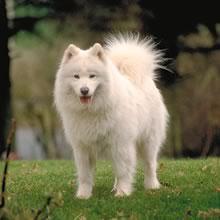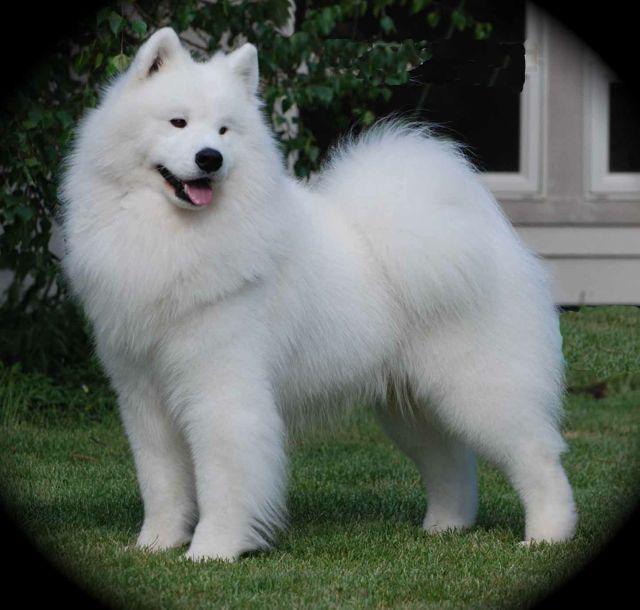The first image is the image on the left, the second image is the image on the right. Analyze the images presented: Is the assertion "One of the images shows an adult dog with a puppy on the grass." valid? Answer yes or no. No. The first image is the image on the left, the second image is the image on the right. For the images shown, is this caption "One image shows a small white pup next to a big white dog on green grass, and the other image contains exactly one white pup on a white surface." true? Answer yes or no. No. 